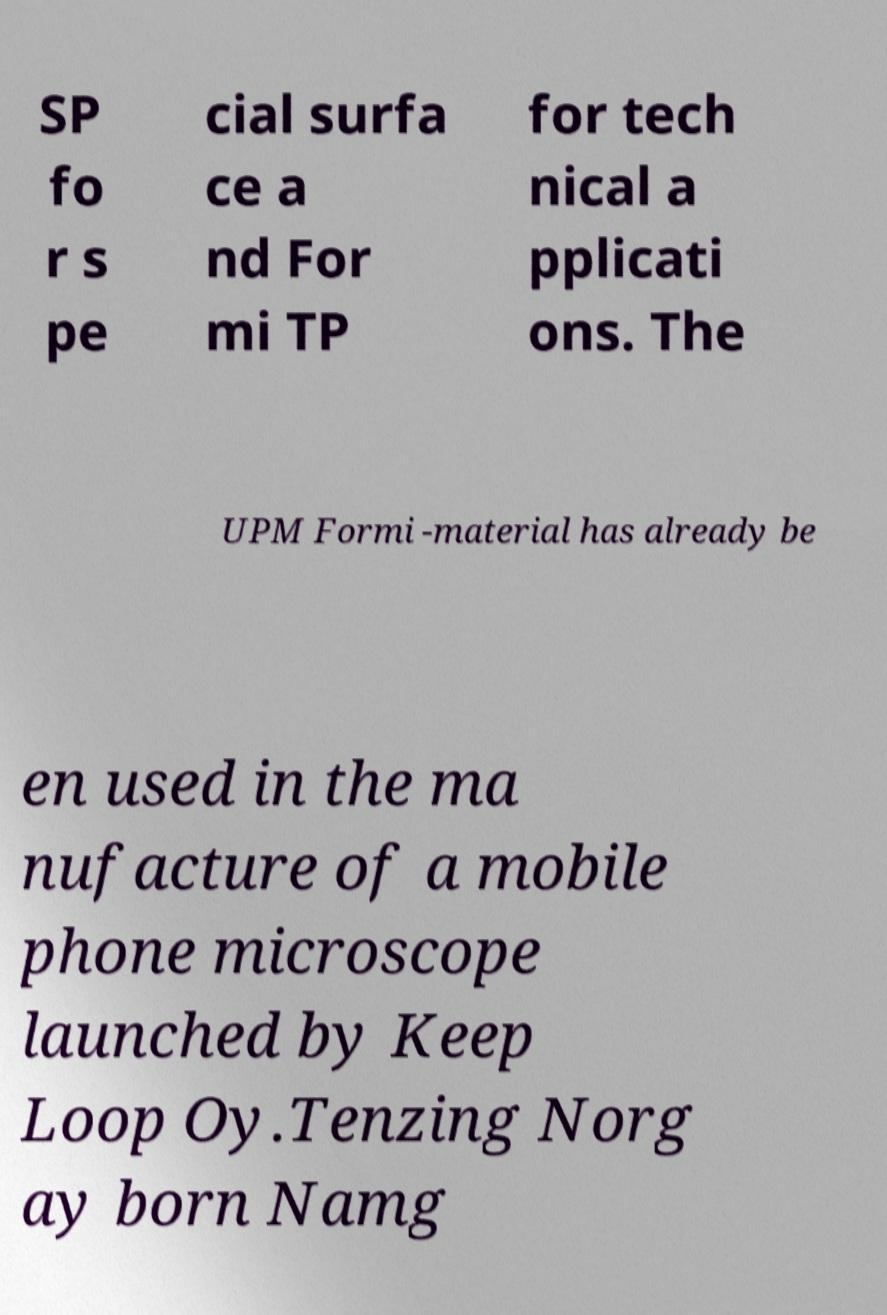Please identify and transcribe the text found in this image. SP fo r s pe cial surfa ce a nd For mi TP for tech nical a pplicati ons. The UPM Formi -material has already be en used in the ma nufacture of a mobile phone microscope launched by Keep Loop Oy.Tenzing Norg ay born Namg 